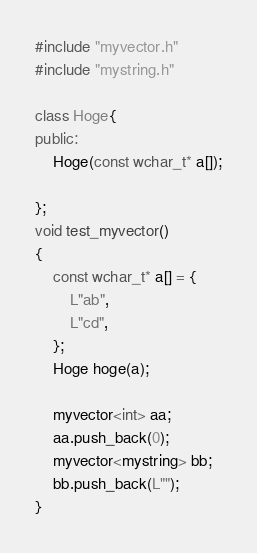<code> <loc_0><loc_0><loc_500><loc_500><_C++_>#include "myvector.h"
#include "mystring.h"

class Hoge{
public:
	Hoge(const wchar_t* a[]);

};
void test_myvector()
{
	const wchar_t* a[] = {
		L"ab",
		L"cd",
	};
	Hoge hoge(a);

	myvector<int> aa;
	aa.push_back(0);
	myvector<mystring> bb;
	bb.push_back(L"");
}</code> 